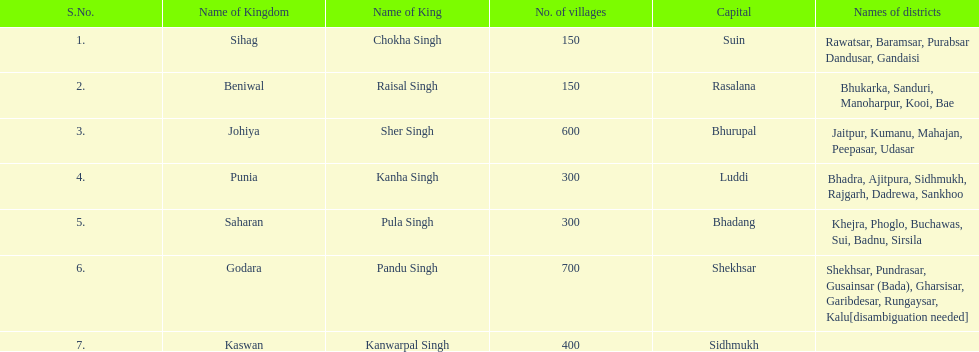Which realm had the second-highest number of villages, following godara? Johiya. 